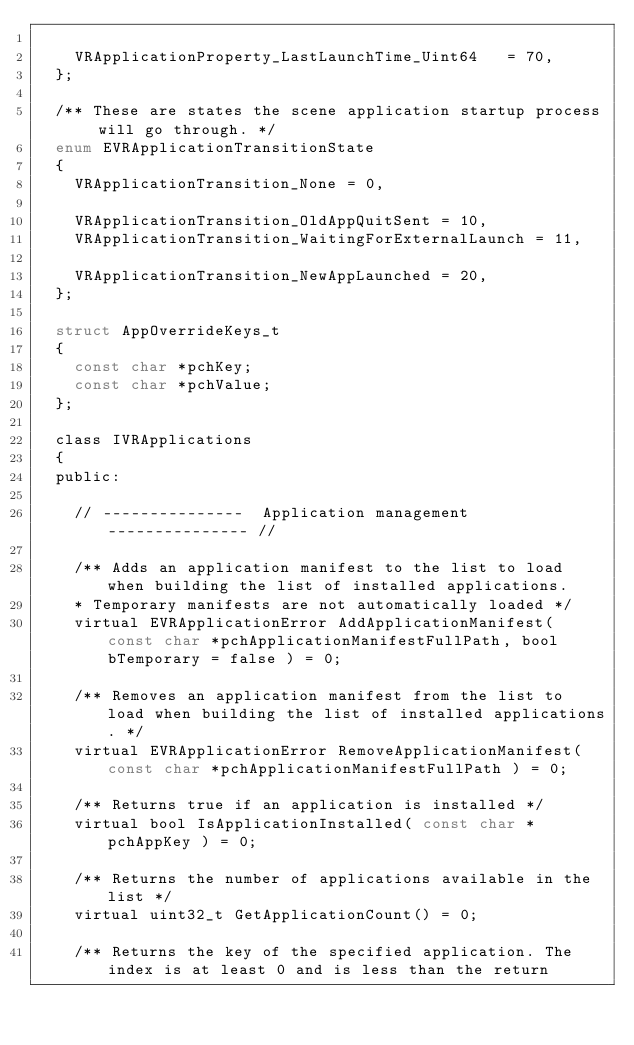Convert code to text. <code><loc_0><loc_0><loc_500><loc_500><_C_>
		VRApplicationProperty_LastLaunchTime_Uint64		= 70,
	};

	/** These are states the scene application startup process will go through. */
	enum EVRApplicationTransitionState
	{
		VRApplicationTransition_None = 0,

		VRApplicationTransition_OldAppQuitSent = 10,
		VRApplicationTransition_WaitingForExternalLaunch = 11,
		
		VRApplicationTransition_NewAppLaunched = 20,
	};

	struct AppOverrideKeys_t
	{
		const char *pchKey;
		const char *pchValue;
	};

	class IVRApplications
	{
	public:

		// ---------------  Application management  --------------- //

		/** Adds an application manifest to the list to load when building the list of installed applications. 
		* Temporary manifests are not automatically loaded */
		virtual EVRApplicationError AddApplicationManifest( const char *pchApplicationManifestFullPath, bool bTemporary = false ) = 0;

		/** Removes an application manifest from the list to load when building the list of installed applications. */
		virtual EVRApplicationError RemoveApplicationManifest( const char *pchApplicationManifestFullPath ) = 0;

		/** Returns true if an application is installed */
		virtual bool IsApplicationInstalled( const char *pchAppKey ) = 0;

		/** Returns the number of applications available in the list */
		virtual uint32_t GetApplicationCount() = 0;

		/** Returns the key of the specified application. The index is at least 0 and is less than the return </code> 